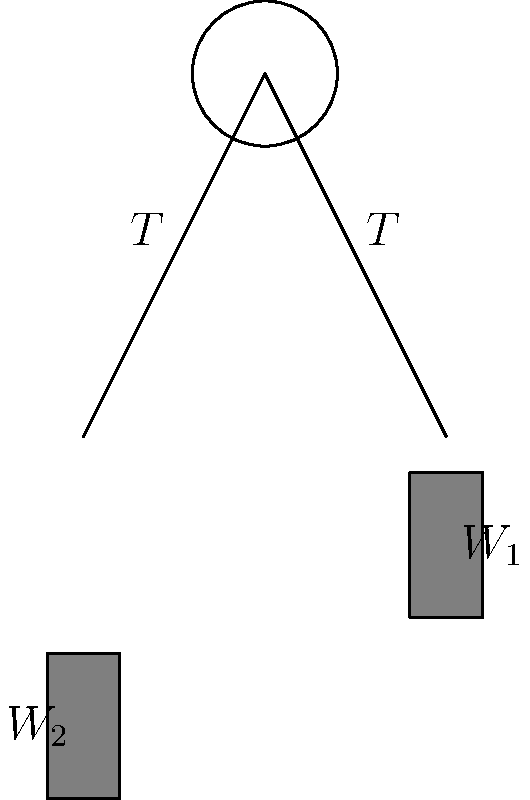In organizing a cultural exchange event, you're setting up a pulley system to raise a banner. The system consists of a fixed pulley with two weights $W_1$ and $W_2$ connected by a rope. If $W_1 = 100$ N and the system is in equilibrium, what is the tension $T$ in the rope? Assume the pulley is frictionless and the rope is massless. To solve this problem, we'll follow these steps:

1) In a pulley system at equilibrium, the tension $T$ is the same throughout the rope.

2) For the system to be in equilibrium, the sum of forces must be zero. In this case, we can consider the vertical forces:

   $$W_1 - T = T - W_2$$

3) We're given that $W_1 = 100$ N. Let's express $W_2$ in terms of $T$:

   $$100 - T = T - W_2$$
   $$100 - T = T - (100 - T)$$
   $$100 - T = 2T - 100$$

4) Now, let's solve for $T$:

   $$200 = 3T$$
   $$T = \frac{200}{3} \approx 66.67 \text{ N}$$

5) We can verify this by calculating $W_2$:

   $$W_2 = 100 - T = 100 - 66.67 = 33.33 \text{ N}$$

6) Indeed, $W_1 (100 \text{ N}) = T + W_2 (66.67 + 33.33 \text{ N})$, confirming the system is in equilibrium.
Answer: $66.67 \text{ N}$ 